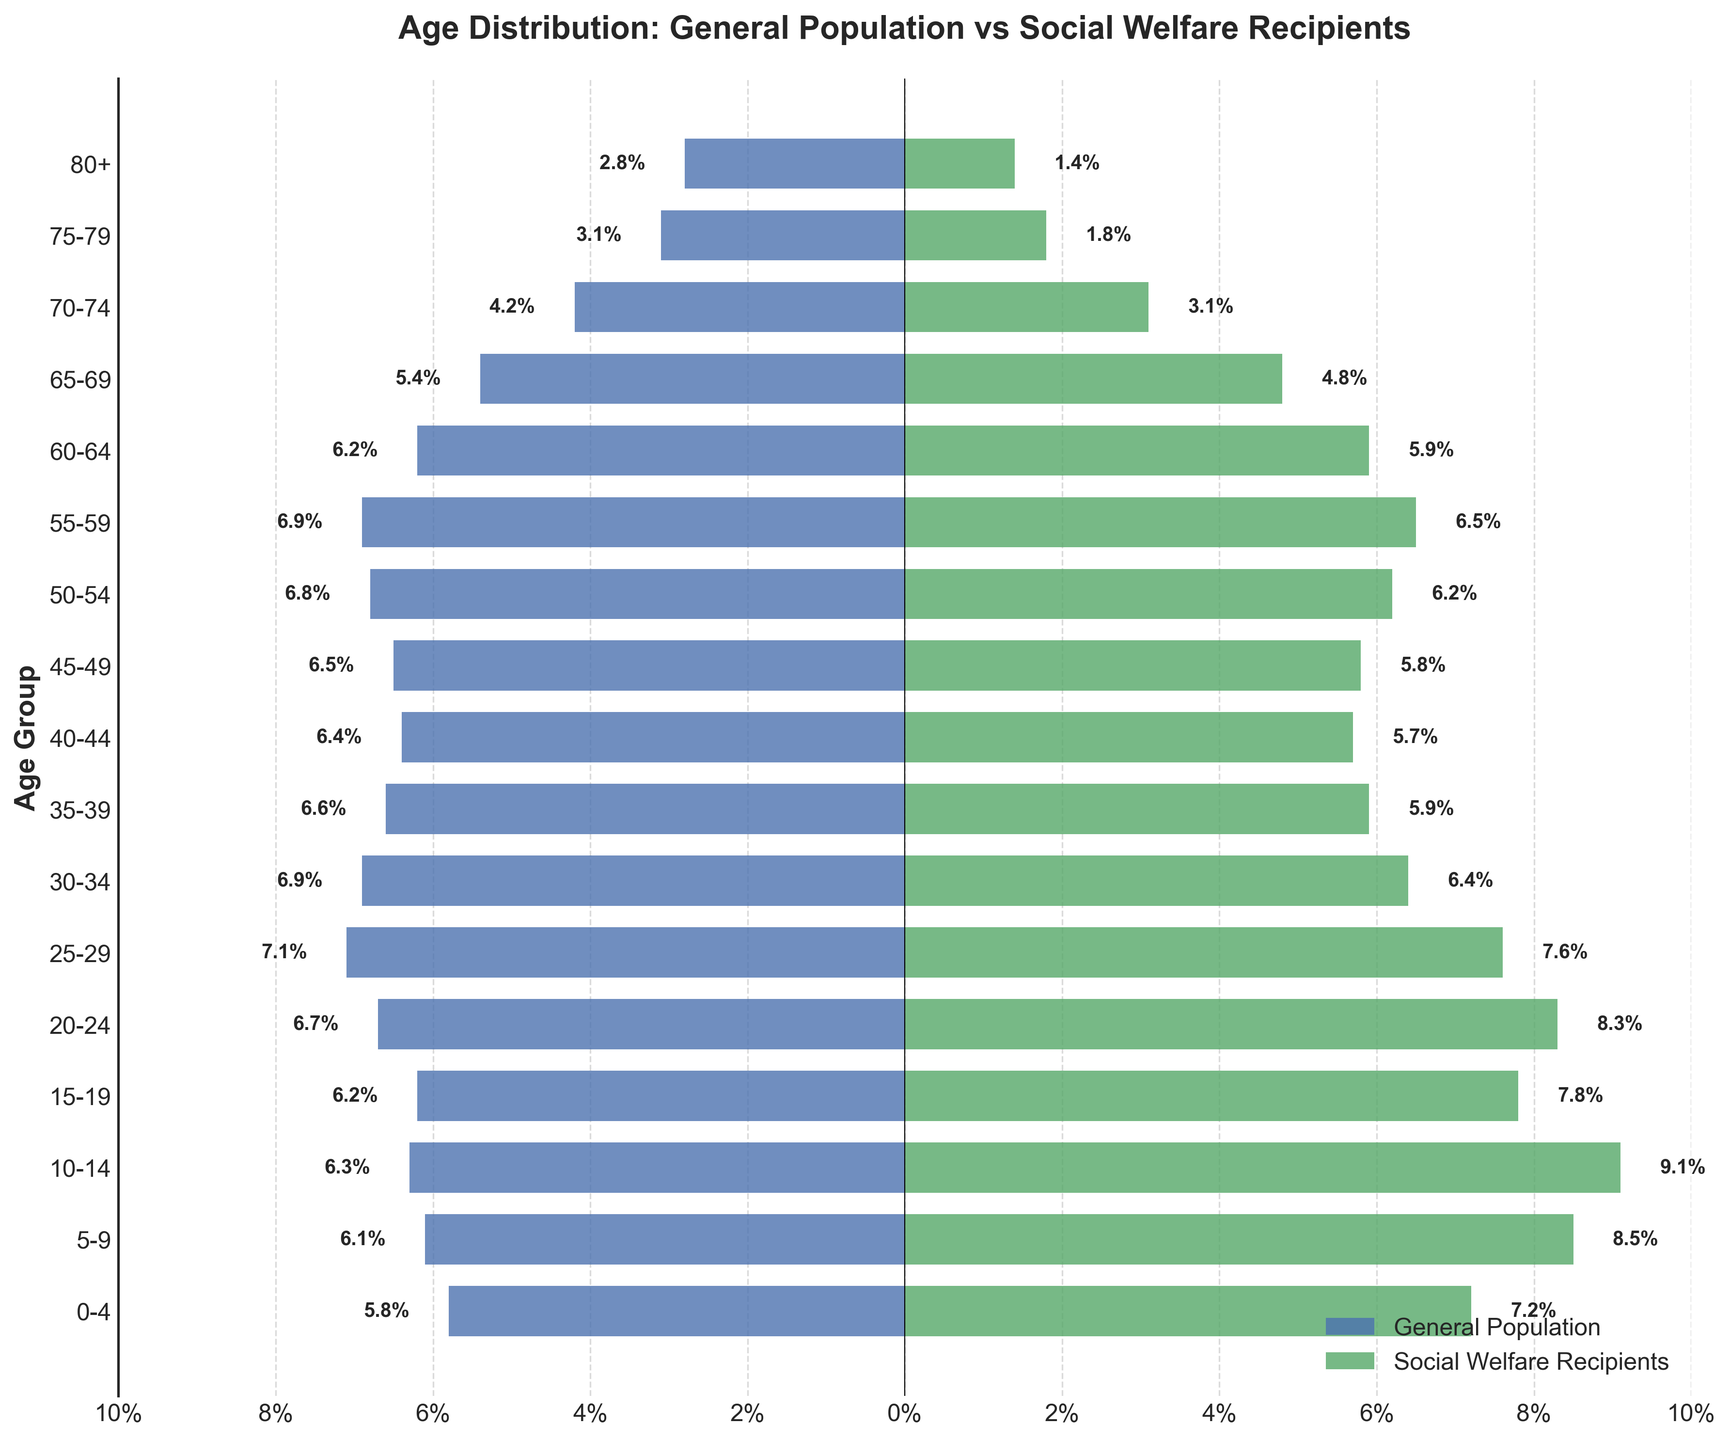What's the title of the figure? The title is usually found at the top of the figure, and it provides a concise description of what the figure represents. Here, the title reads, "Age Distribution: General Population vs Social Welfare Recipients".
Answer: Age Distribution: General Population vs Social Welfare Recipients What age group has the highest percentage of social welfare recipients? The highest bar on the side representing social welfare recipients indicates the age group with the highest percentage. Here, the "10-14" age group has the highest bar, indicating 9.1%.
Answer: 10-14 Which age group has a higher percentage in the general population compared to social welfare recipients? Compare the lengths of the horizontal bars for each age group. The "70-74" age group has a longer bar on the general population side (4.2%) than on the social welfare recipient side (3.1%).
Answer: 70-74 How does the percentage of social welfare recipients in the "0-4" age group compare to the general population? The bar on the social welfare recipients' side for the "0-4" age group is slightly longer. The percentage for social welfare recipients is 7.2%, whereas for the general population, it is 5.8%.
Answer: Higher by 1.4% What is the total percentage of the general population for the "20-24" and "25-29" age groups combined? Locate the percentages for these groups in the general population side and add them up: 6.7% (20-24) + 7.1% (25-29) = 13.8%.
Answer: 13.8% Which age group has the closest percentage between the general population and social welfare recipients? Compare the bars to see which pair have the closest lengths. The "55-59" age group has percentages of 6.9% (general population) and 6.5% (social welfare recipients), showing a 0.4% difference. This is the smallest disparity.
Answer: 55-59 At what age group do social welfare recipients' percentages start declining more dramatically compared to the general population? By observing the bars, we see a clear decline starting at the "30-34" age group and continuing downwards. The percentages drop more dramatically after the "25-29" age group.
Answer: 30-34 What is the percentage difference between the general population and social welfare recipients for the "80+" age group? For the "80+" age group, the general population percentage is 2.8%, while for social welfare recipients, it is 1.4%. The difference is 2.8% - 1.4% = 1.4%.
Answer: 1.4% How do the trends of percentages generally compare between the two sides as the age groups increase? The general trend shows that the percentage of social welfare recipients remains higher than the general population in younger age groups (0-29), but the trend reverses from middle age (30-80+), where the general population has higher percentages.
Answer: Higher in younger, lower in older Is there a significant percentage of social welfare recipients beyond the age of 60? Examine the bars for age groups beyond 60. All percentages for social welfare recipients are less than 6%, indicating a relatively low representation in these age groups.
Answer: No 